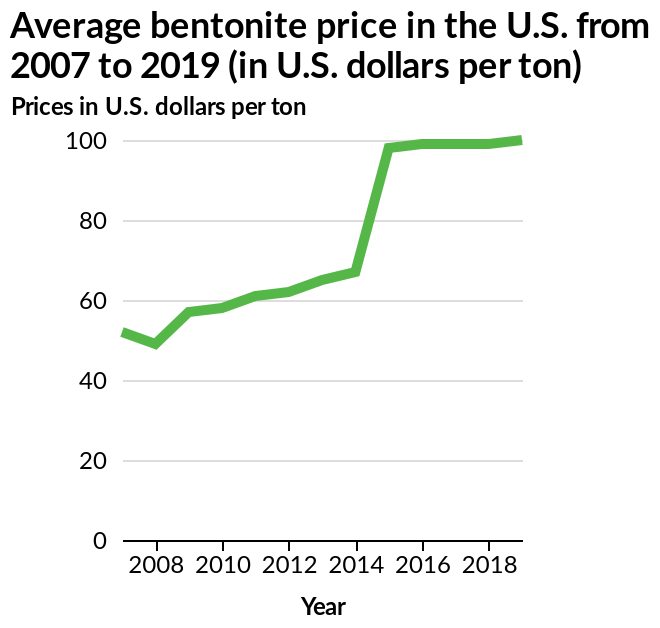<image>
What is the unit of measurement for the prices on the y-axis? The prices on the y-axis are measured in U.S. dollars per ton. What is the overall timeframe covered by the line chart? The line chart covers the period from 2007 to 2019, showing the average bentonite prices in the U.S. over that time. What is the range of the y-axis on the line chart? The y-axis on the line chart has a linear scale of range 0 to 100. 